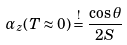<formula> <loc_0><loc_0><loc_500><loc_500>\alpha _ { z } ( T \approx 0 ) \stackrel { ! } { = } \frac { \cos \theta } { 2 S }</formula> 